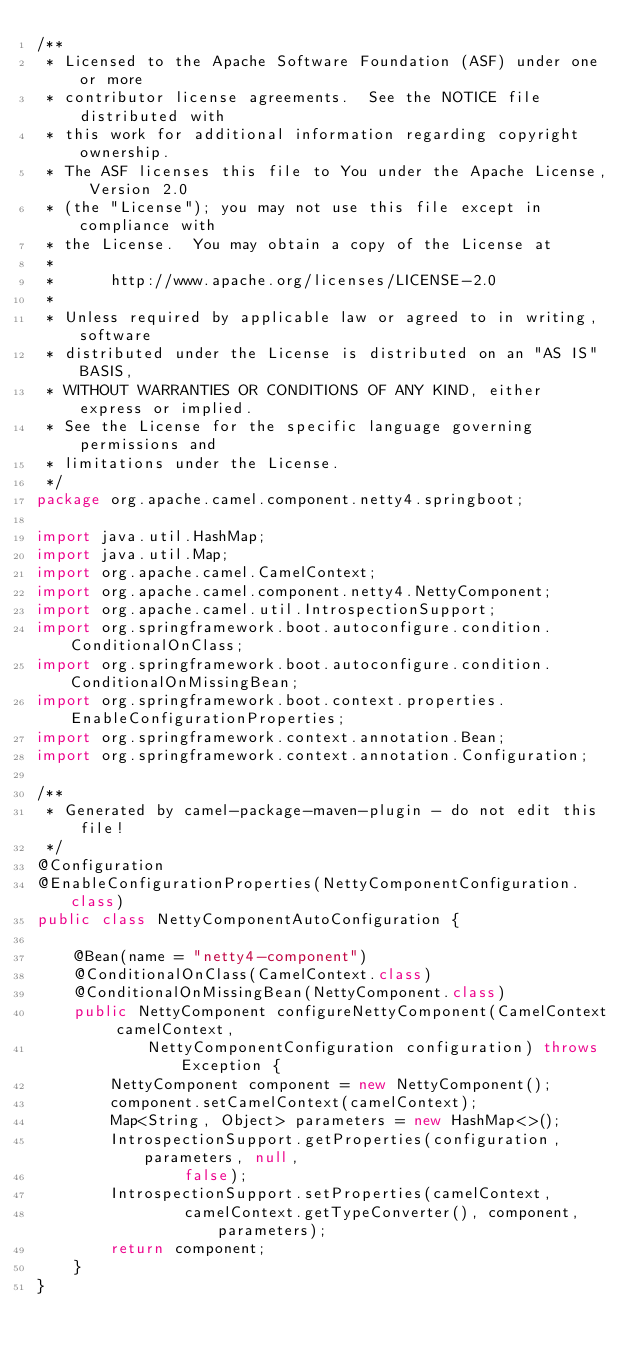Convert code to text. <code><loc_0><loc_0><loc_500><loc_500><_Java_>/**
 * Licensed to the Apache Software Foundation (ASF) under one or more
 * contributor license agreements.  See the NOTICE file distributed with
 * this work for additional information regarding copyright ownership.
 * The ASF licenses this file to You under the Apache License, Version 2.0
 * (the "License"); you may not use this file except in compliance with
 * the License.  You may obtain a copy of the License at
 *
 *      http://www.apache.org/licenses/LICENSE-2.0
 *
 * Unless required by applicable law or agreed to in writing, software
 * distributed under the License is distributed on an "AS IS" BASIS,
 * WITHOUT WARRANTIES OR CONDITIONS OF ANY KIND, either express or implied.
 * See the License for the specific language governing permissions and
 * limitations under the License.
 */
package org.apache.camel.component.netty4.springboot;

import java.util.HashMap;
import java.util.Map;
import org.apache.camel.CamelContext;
import org.apache.camel.component.netty4.NettyComponent;
import org.apache.camel.util.IntrospectionSupport;
import org.springframework.boot.autoconfigure.condition.ConditionalOnClass;
import org.springframework.boot.autoconfigure.condition.ConditionalOnMissingBean;
import org.springframework.boot.context.properties.EnableConfigurationProperties;
import org.springframework.context.annotation.Bean;
import org.springframework.context.annotation.Configuration;

/**
 * Generated by camel-package-maven-plugin - do not edit this file!
 */
@Configuration
@EnableConfigurationProperties(NettyComponentConfiguration.class)
public class NettyComponentAutoConfiguration {

    @Bean(name = "netty4-component")
    @ConditionalOnClass(CamelContext.class)
    @ConditionalOnMissingBean(NettyComponent.class)
    public NettyComponent configureNettyComponent(CamelContext camelContext,
            NettyComponentConfiguration configuration) throws Exception {
        NettyComponent component = new NettyComponent();
        component.setCamelContext(camelContext);
        Map<String, Object> parameters = new HashMap<>();
        IntrospectionSupport.getProperties(configuration, parameters, null,
                false);
        IntrospectionSupport.setProperties(camelContext,
                camelContext.getTypeConverter(), component, parameters);
        return component;
    }
}</code> 